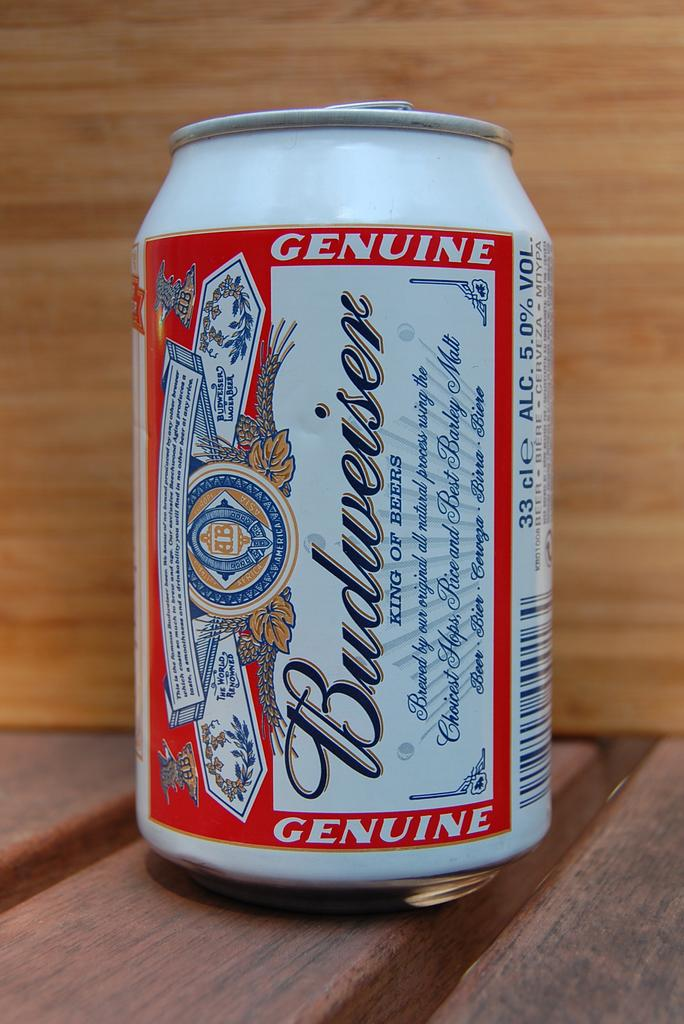<image>
Write a terse but informative summary of the picture. A bottle of Budweiser on a wooden table. 